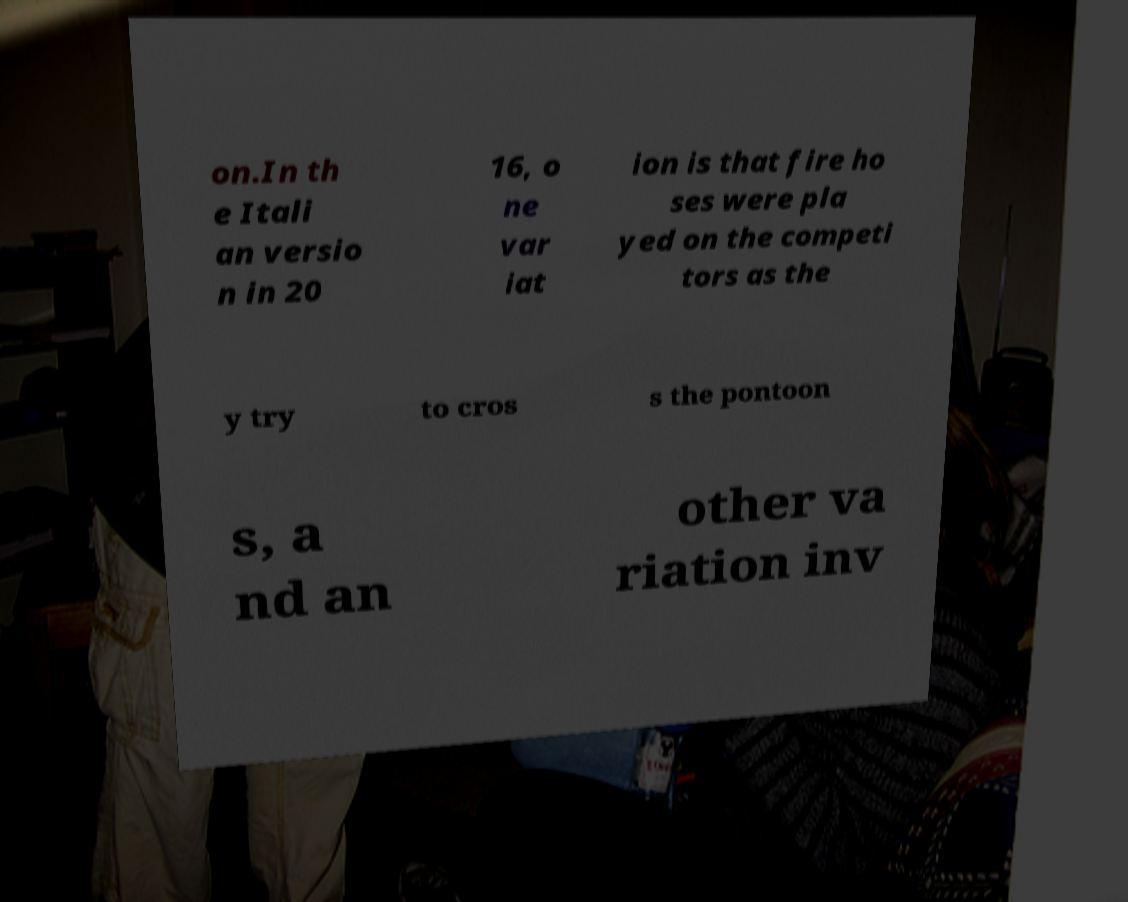What messages or text are displayed in this image? I need them in a readable, typed format. on.In th e Itali an versio n in 20 16, o ne var iat ion is that fire ho ses were pla yed on the competi tors as the y try to cros s the pontoon s, a nd an other va riation inv 